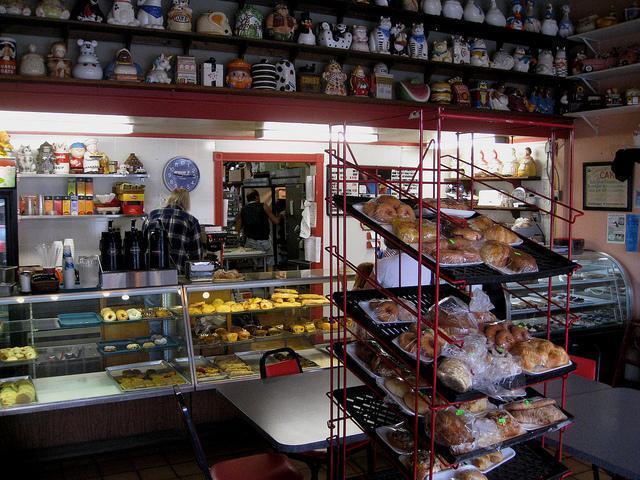What type of items are on the rack in front?
Choose the right answer from the provided options to respond to the question.
Options: Raw, day old, overdone, freshest. Day old. 